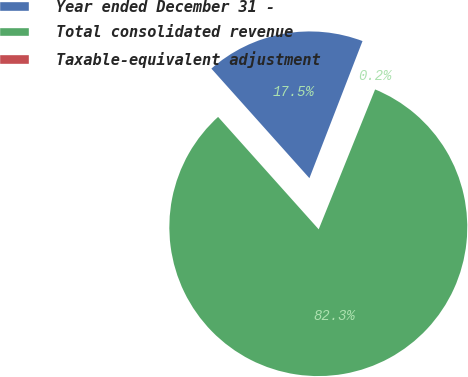Convert chart. <chart><loc_0><loc_0><loc_500><loc_500><pie_chart><fcel>Year ended December 31 -<fcel>Total consolidated revenue<fcel>Taxable-equivalent adjustment<nl><fcel>17.5%<fcel>82.28%<fcel>0.22%<nl></chart> 